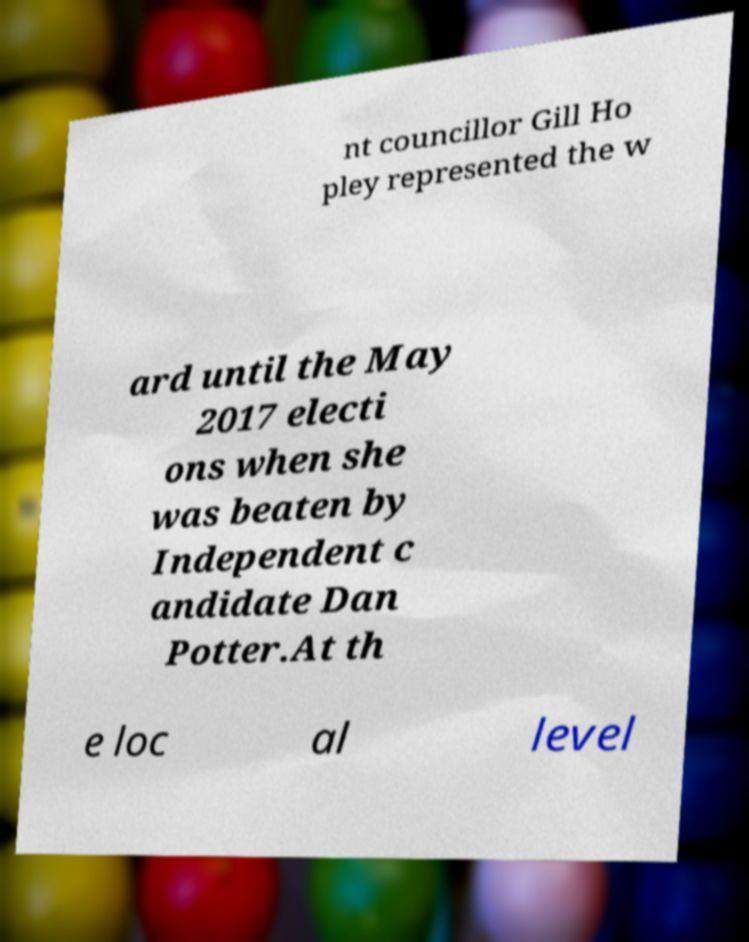For documentation purposes, I need the text within this image transcribed. Could you provide that? nt councillor Gill Ho pley represented the w ard until the May 2017 electi ons when she was beaten by Independent c andidate Dan Potter.At th e loc al level 